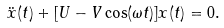<formula> <loc_0><loc_0><loc_500><loc_500>\ddot { x } ( t ) + [ U - V \cos ( \omega t ) ] x ( t ) = 0 .</formula> 